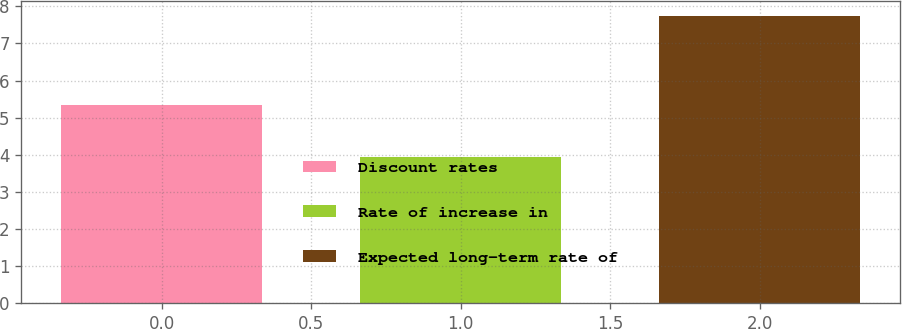<chart> <loc_0><loc_0><loc_500><loc_500><bar_chart><fcel>Discount rates<fcel>Rate of increase in<fcel>Expected long-term rate of<nl><fcel>5.34<fcel>3.93<fcel>7.75<nl></chart> 